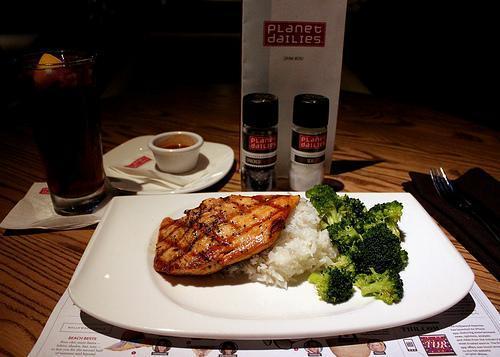How many pieces of meat are on the plate?
Give a very brief answer. 1. 